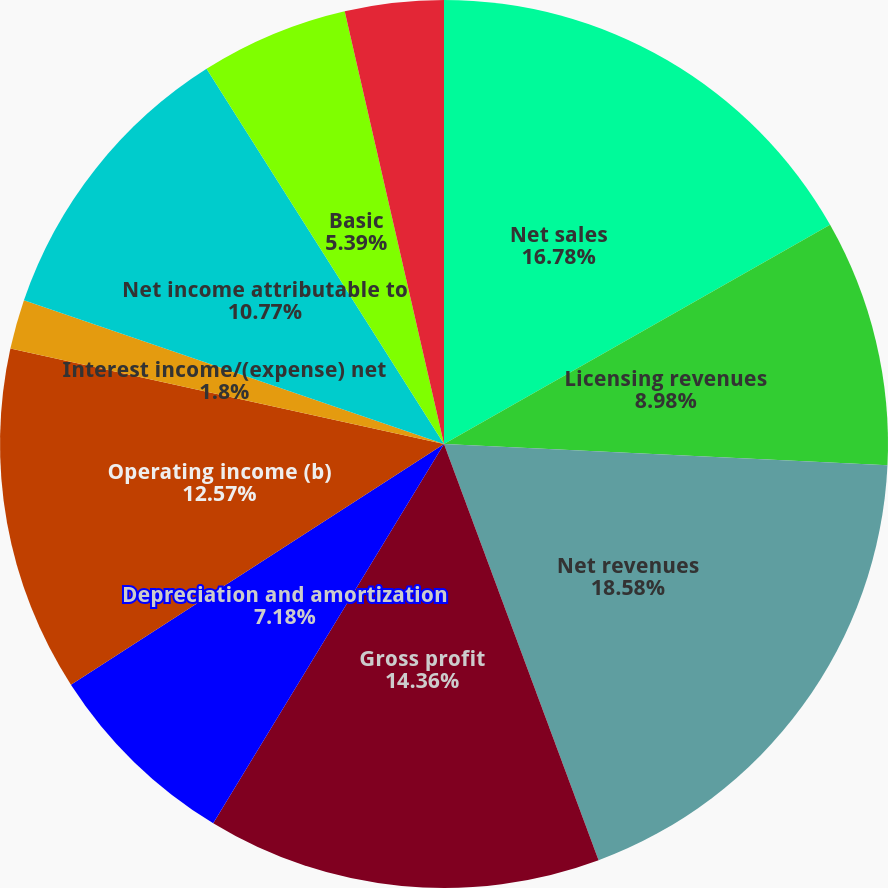<chart> <loc_0><loc_0><loc_500><loc_500><pie_chart><fcel>Net sales<fcel>Licensing revenues<fcel>Net revenues<fcel>Gross profit<fcel>Depreciation and amortization<fcel>Operating income (b)<fcel>Interest income/(expense) net<fcel>Net income attributable to<fcel>Basic<fcel>Diluted<nl><fcel>16.78%<fcel>8.98%<fcel>18.58%<fcel>14.36%<fcel>7.18%<fcel>12.57%<fcel>1.8%<fcel>10.77%<fcel>5.39%<fcel>3.59%<nl></chart> 